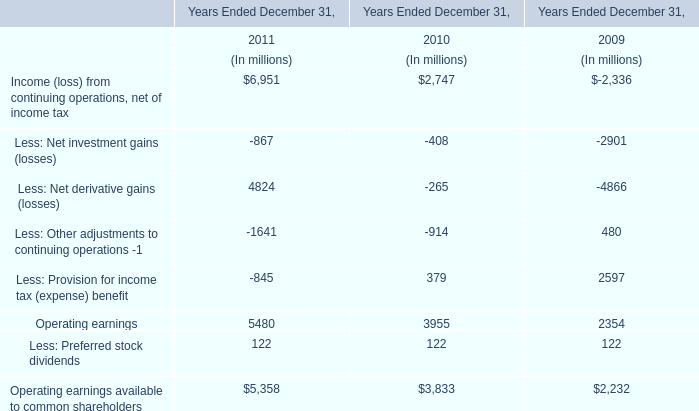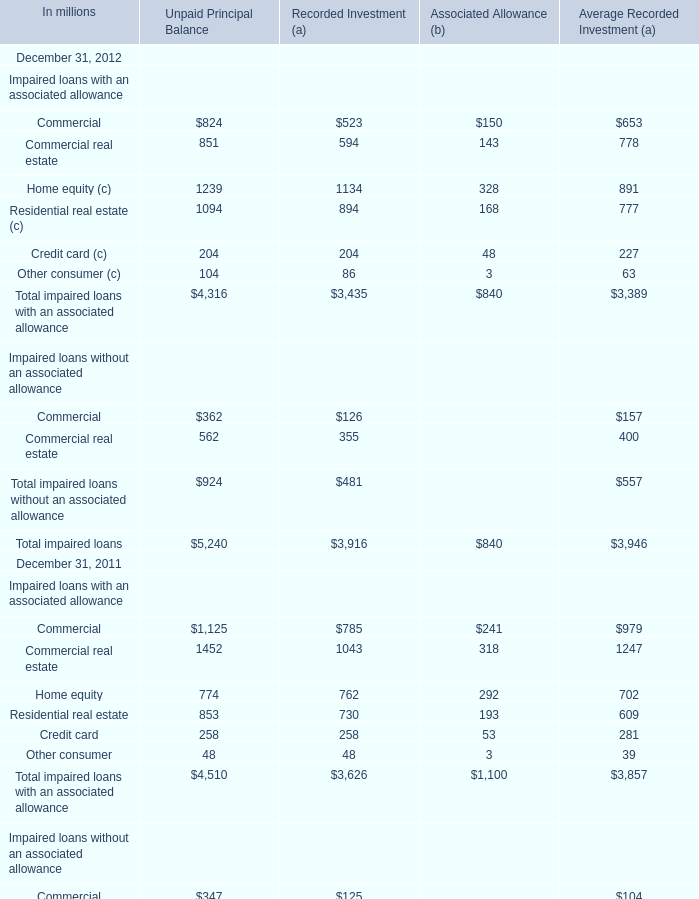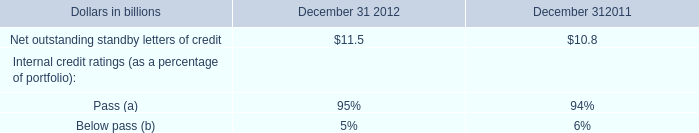in billions , what was the change between 2011 and 2012 in net outstanding standby letters of credit? 
Computations: ((11.5 + 10.8) / 2)
Answer: 11.15. 